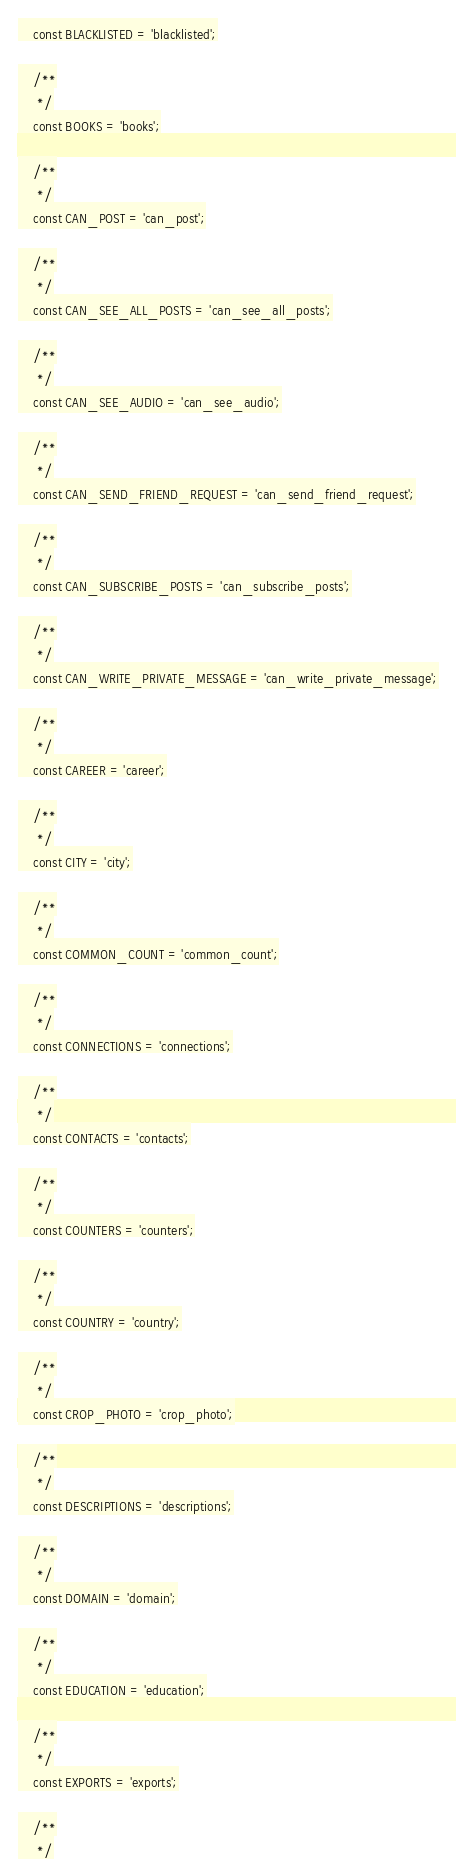<code> <loc_0><loc_0><loc_500><loc_500><_PHP_>	const BLACKLISTED = 'blacklisted';

	/**
	 */
	const BOOKS = 'books';

	/**
	 */
	const CAN_POST = 'can_post';

	/**
	 */
	const CAN_SEE_ALL_POSTS = 'can_see_all_posts';

	/**
	 */
	const CAN_SEE_AUDIO = 'can_see_audio';

	/**
	 */
	const CAN_SEND_FRIEND_REQUEST = 'can_send_friend_request';

	/**
	 */
	const CAN_SUBSCRIBE_POSTS = 'can_subscribe_posts';

	/**
	 */
	const CAN_WRITE_PRIVATE_MESSAGE = 'can_write_private_message';

	/**
	 */
	const CAREER = 'career';

	/**
	 */
	const CITY = 'city';

	/**
	 */
	const COMMON_COUNT = 'common_count';

	/**
	 */
	const CONNECTIONS = 'connections';

	/**
	 */
	const CONTACTS = 'contacts';

	/**
	 */
	const COUNTERS = 'counters';

	/**
	 */
	const COUNTRY = 'country';

	/**
	 */
	const CROP_PHOTO = 'crop_photo';

	/**
	 */
	const DESCRIPTIONS = 'descriptions';

	/**
	 */
	const DOMAIN = 'domain';

	/**
	 */
	const EDUCATION = 'education';

	/**
	 */
	const EXPORTS = 'exports';

	/**
	 */</code> 